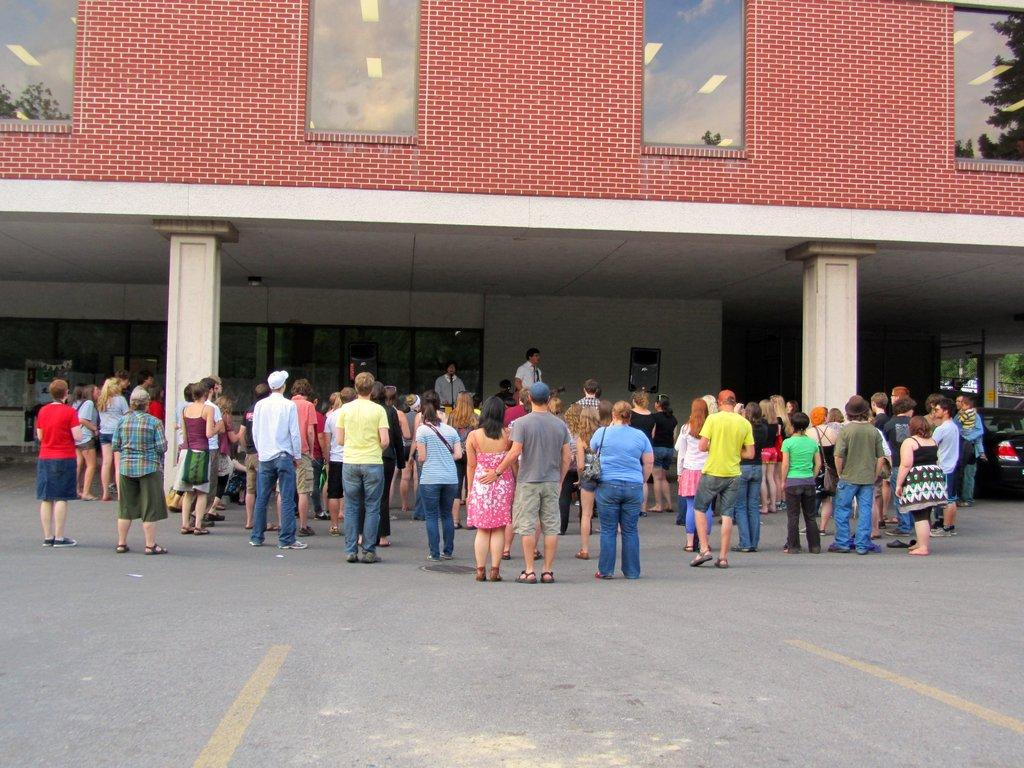What can be seen in the image involving multiple individuals? There are groups of people standing in the image. What are some people in the groups wearing? Some people in the groups are wearing bags. What can be seen in the background of the image? There is a building in the background of the image, with windows and pillars visible. What else is present in the background of the image? A vehicle is present in the background of the image. Can you tell me how many horses are visible in the image? There are no horses present in the image. What type of medical facility is depicted in the image? The image does not depict a hospital or any medical facility; it features groups of people and a building in the background. 